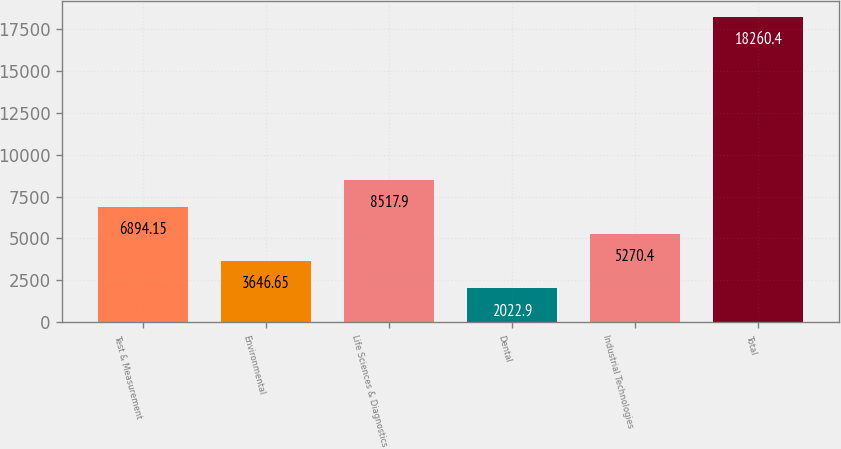<chart> <loc_0><loc_0><loc_500><loc_500><bar_chart><fcel>Test & Measurement<fcel>Environmental<fcel>Life Sciences & Diagnostics<fcel>Dental<fcel>Industrial Technologies<fcel>Total<nl><fcel>6894.15<fcel>3646.65<fcel>8517.9<fcel>2022.9<fcel>5270.4<fcel>18260.4<nl></chart> 